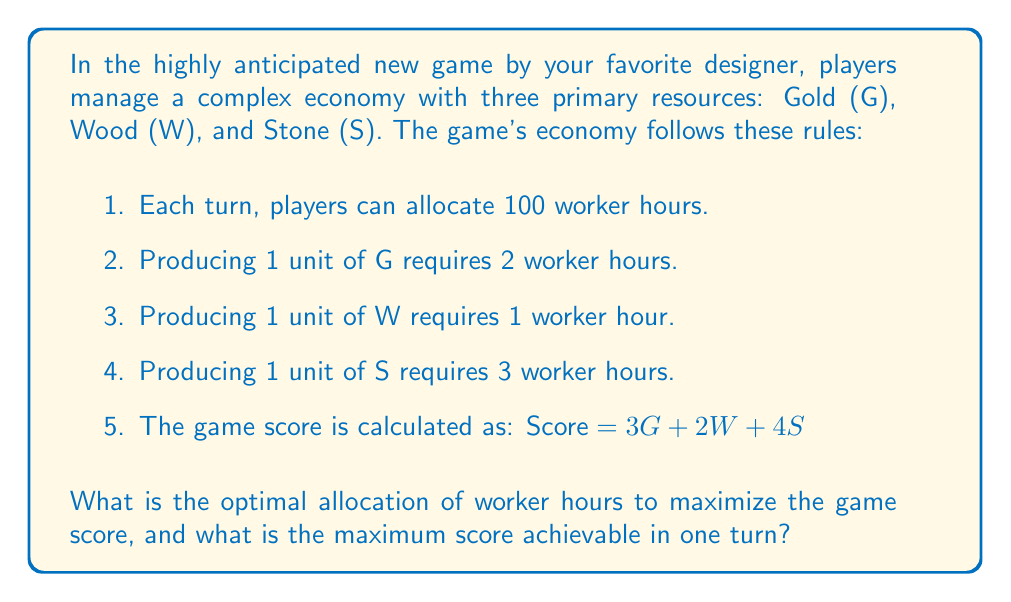Show me your answer to this math problem. To solve this problem, we'll use linear programming techniques, which are often employed in game theory for resource allocation problems.

Let's define our variables:
$x$ = worker hours allocated to Gold
$y$ = worker hours allocated to Wood
$z$ = worker hours allocated to Stone

We can set up our objective function (the score) and constraints:

Maximize: $Score = 3(\frac{x}{2}) + 2y + 4(\frac{z}{3})$

Subject to:
1. $x + y + z \leq 100$ (total worker hours constraint)
2. $x, y, z \geq 0$ (non-negativity constraints)

Simplifying the objective function:
$Score = \frac{3x}{2} + 2y + \frac{4z}{3}$

To find the optimal solution, we need to compare the coefficients of x, y, and z in the objective function:

For x: $\frac{3}{2} = 1.5$
For y: $2$
For z: $\frac{4}{3} \approx 1.33$

The highest coefficient is for y (Wood), so we should allocate as many worker hours as possible to Wood production.

Optimal allocation:
y = 100 (allocate all 100 worker hours to Wood)
x = 0
z = 0

Maximum score:
$Score = \frac{3(0)}{2} + 2(100) + \frac{4(0)}{3} = 200$
Answer: The optimal allocation is to assign all 100 worker hours to Wood production. The maximum achievable score in one turn is 200. 